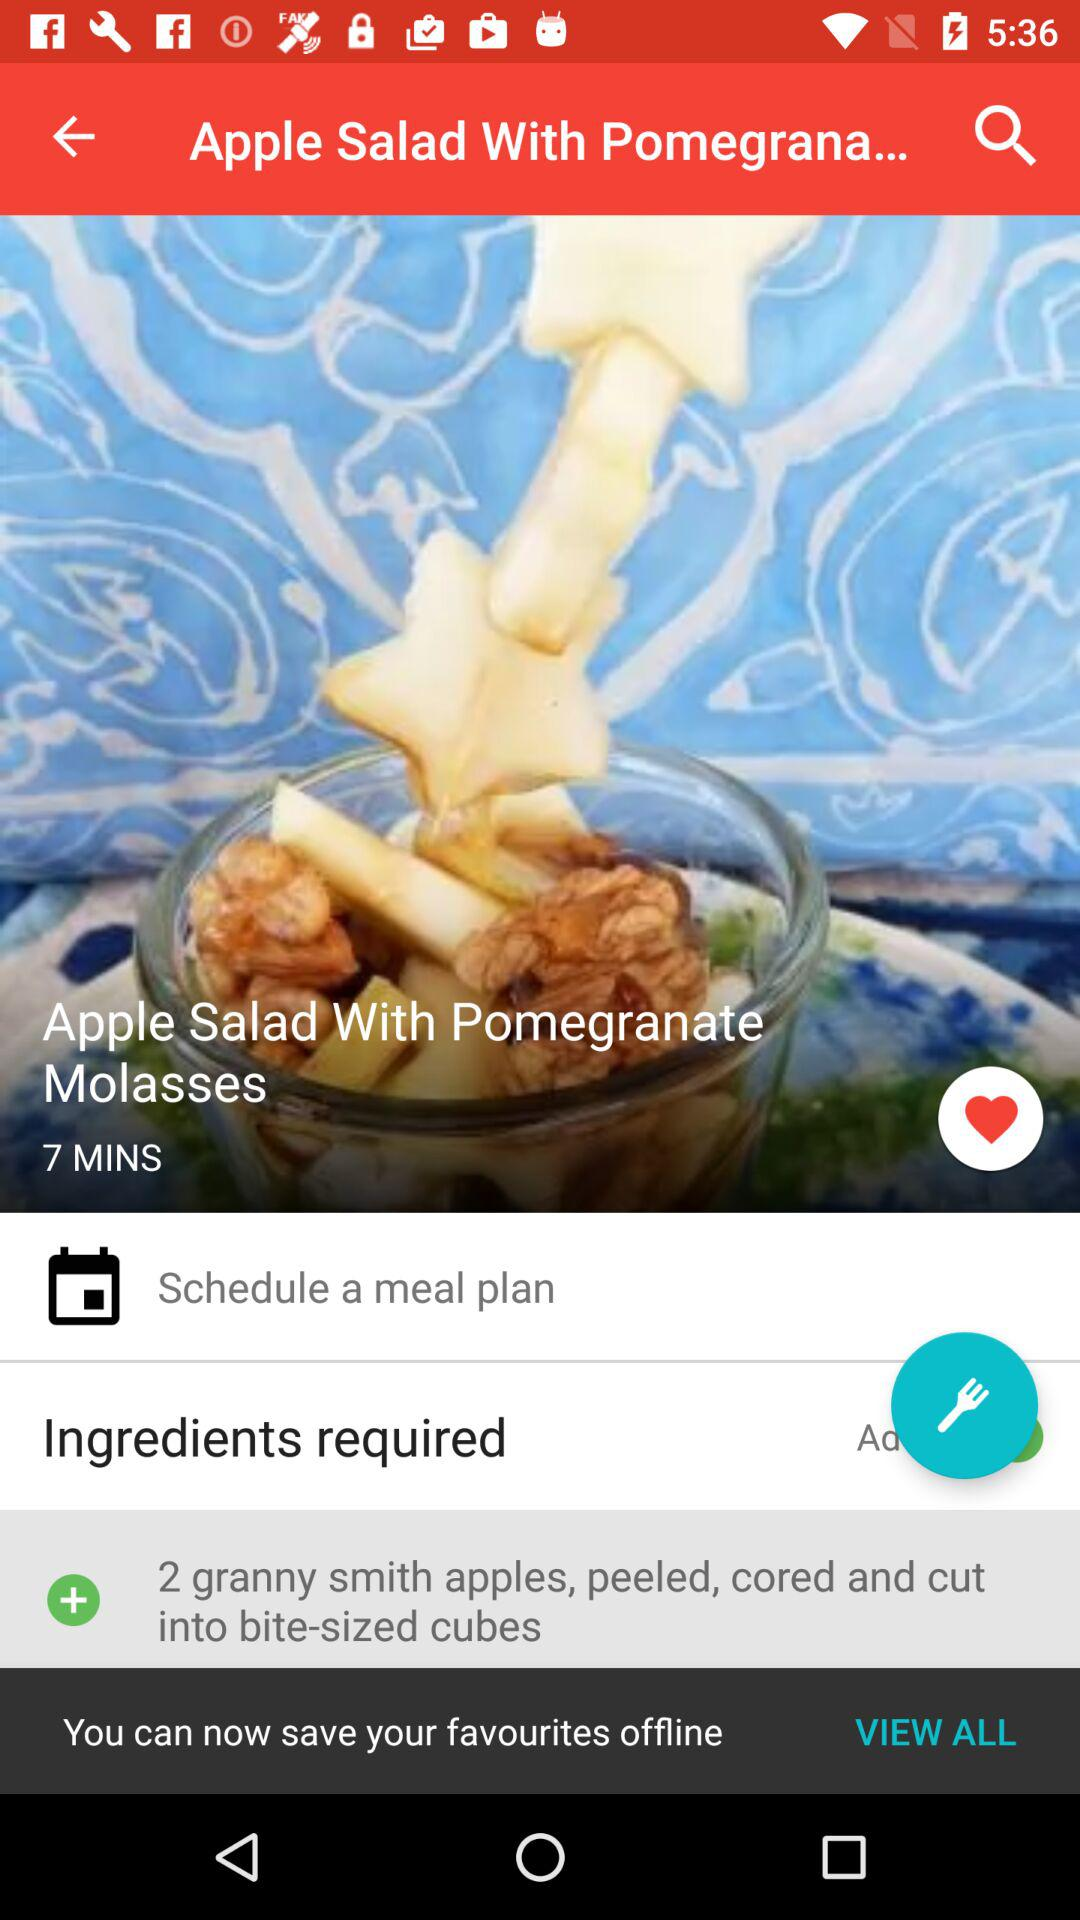What is the dish name? The dish name is "Apple Salad With Pomegranate Molasses". 